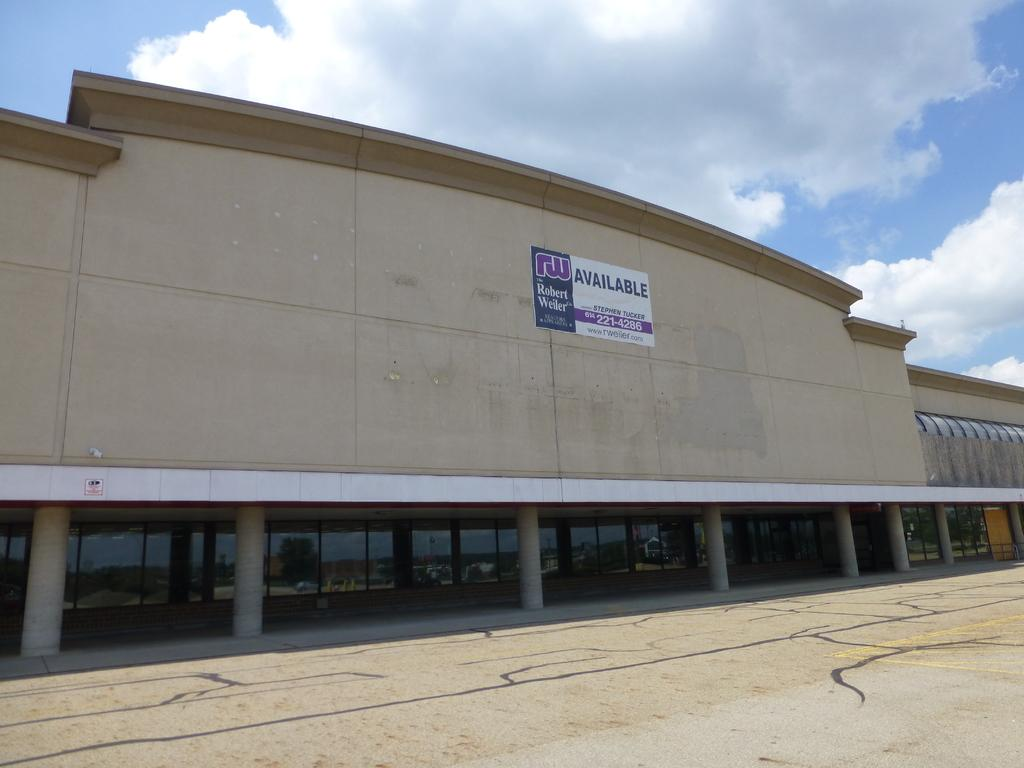What is the main structure in the middle of the image? There is a building in the middle of the image. What type of windows does the building have? The building has glass windows. What architectural feature can be seen supporting the building? The building has pillars. What is located in front of the building? There is a road in front of the building. What is visible at the top of the image? The sky is visible at the top of the image. What type of knife is being used to cut the apple in the image? There is no knife or apple present in the image; it features a building with glass windows and pillars, a road in front, and a visible sky. 